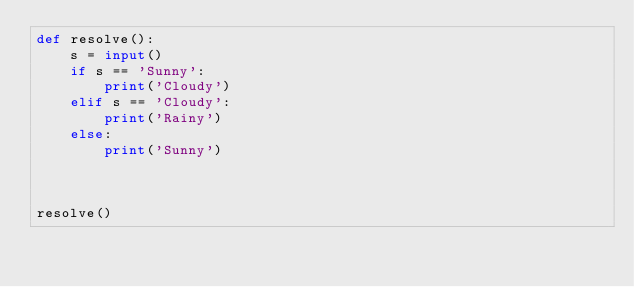<code> <loc_0><loc_0><loc_500><loc_500><_Python_>def resolve():
    s = input()
    if s == 'Sunny':
        print('Cloudy')
    elif s == 'Cloudy':
        print('Rainy')
    else:
        print('Sunny')



resolve()</code> 